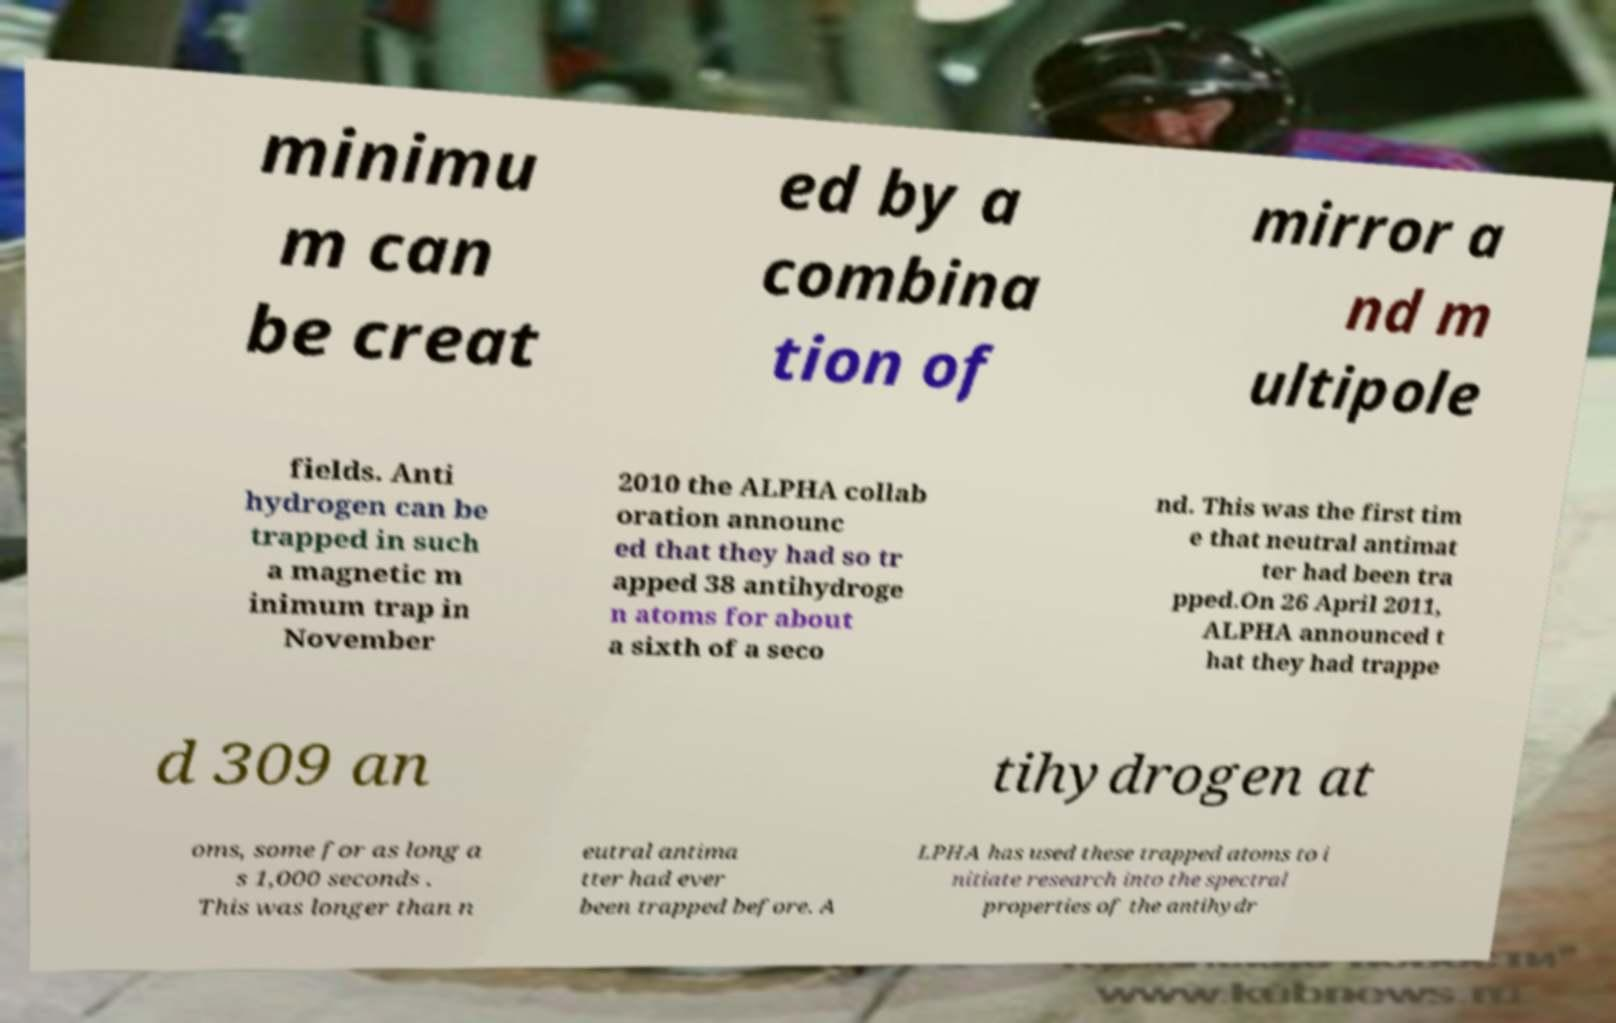Could you extract and type out the text from this image? minimu m can be creat ed by a combina tion of mirror a nd m ultipole fields. Anti hydrogen can be trapped in such a magnetic m inimum trap in November 2010 the ALPHA collab oration announc ed that they had so tr apped 38 antihydroge n atoms for about a sixth of a seco nd. This was the first tim e that neutral antimat ter had been tra pped.On 26 April 2011, ALPHA announced t hat they had trappe d 309 an tihydrogen at oms, some for as long a s 1,000 seconds . This was longer than n eutral antima tter had ever been trapped before. A LPHA has used these trapped atoms to i nitiate research into the spectral properties of the antihydr 